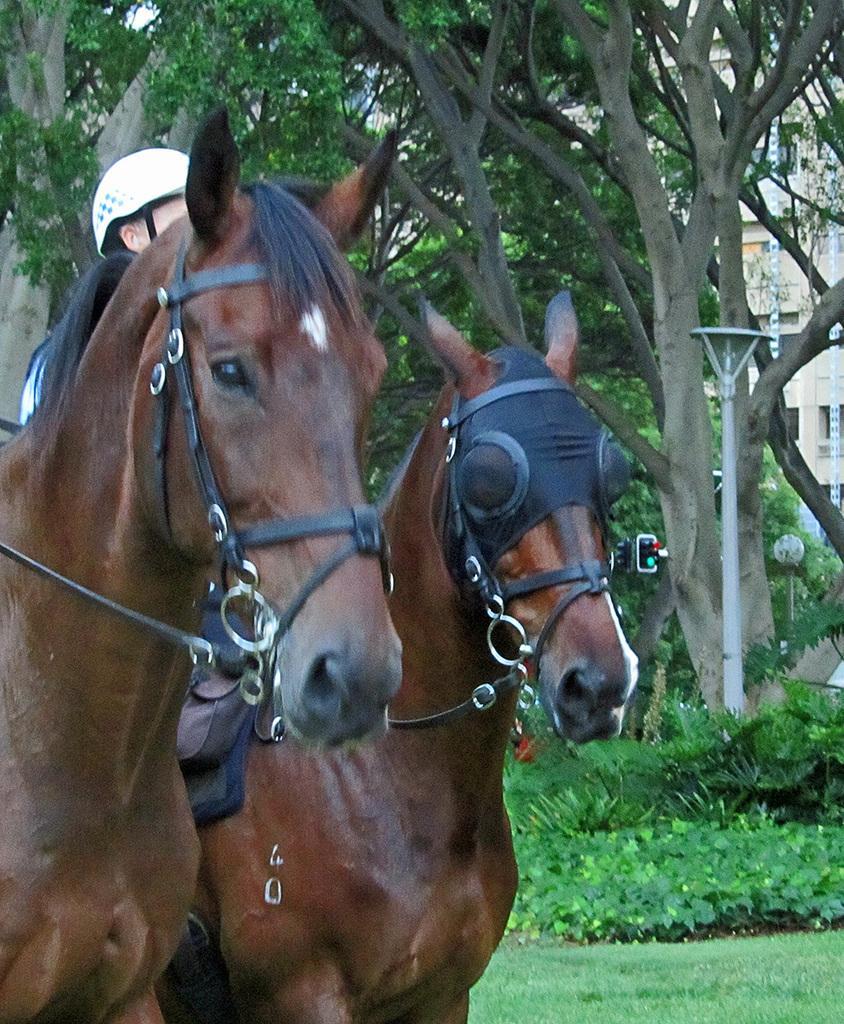How would you summarize this image in a sentence or two? In the center of the image we can see a man sitting on the horse. On the left side of the image we can see a horse. In the background there are trees, building, poles, plants and grass. 